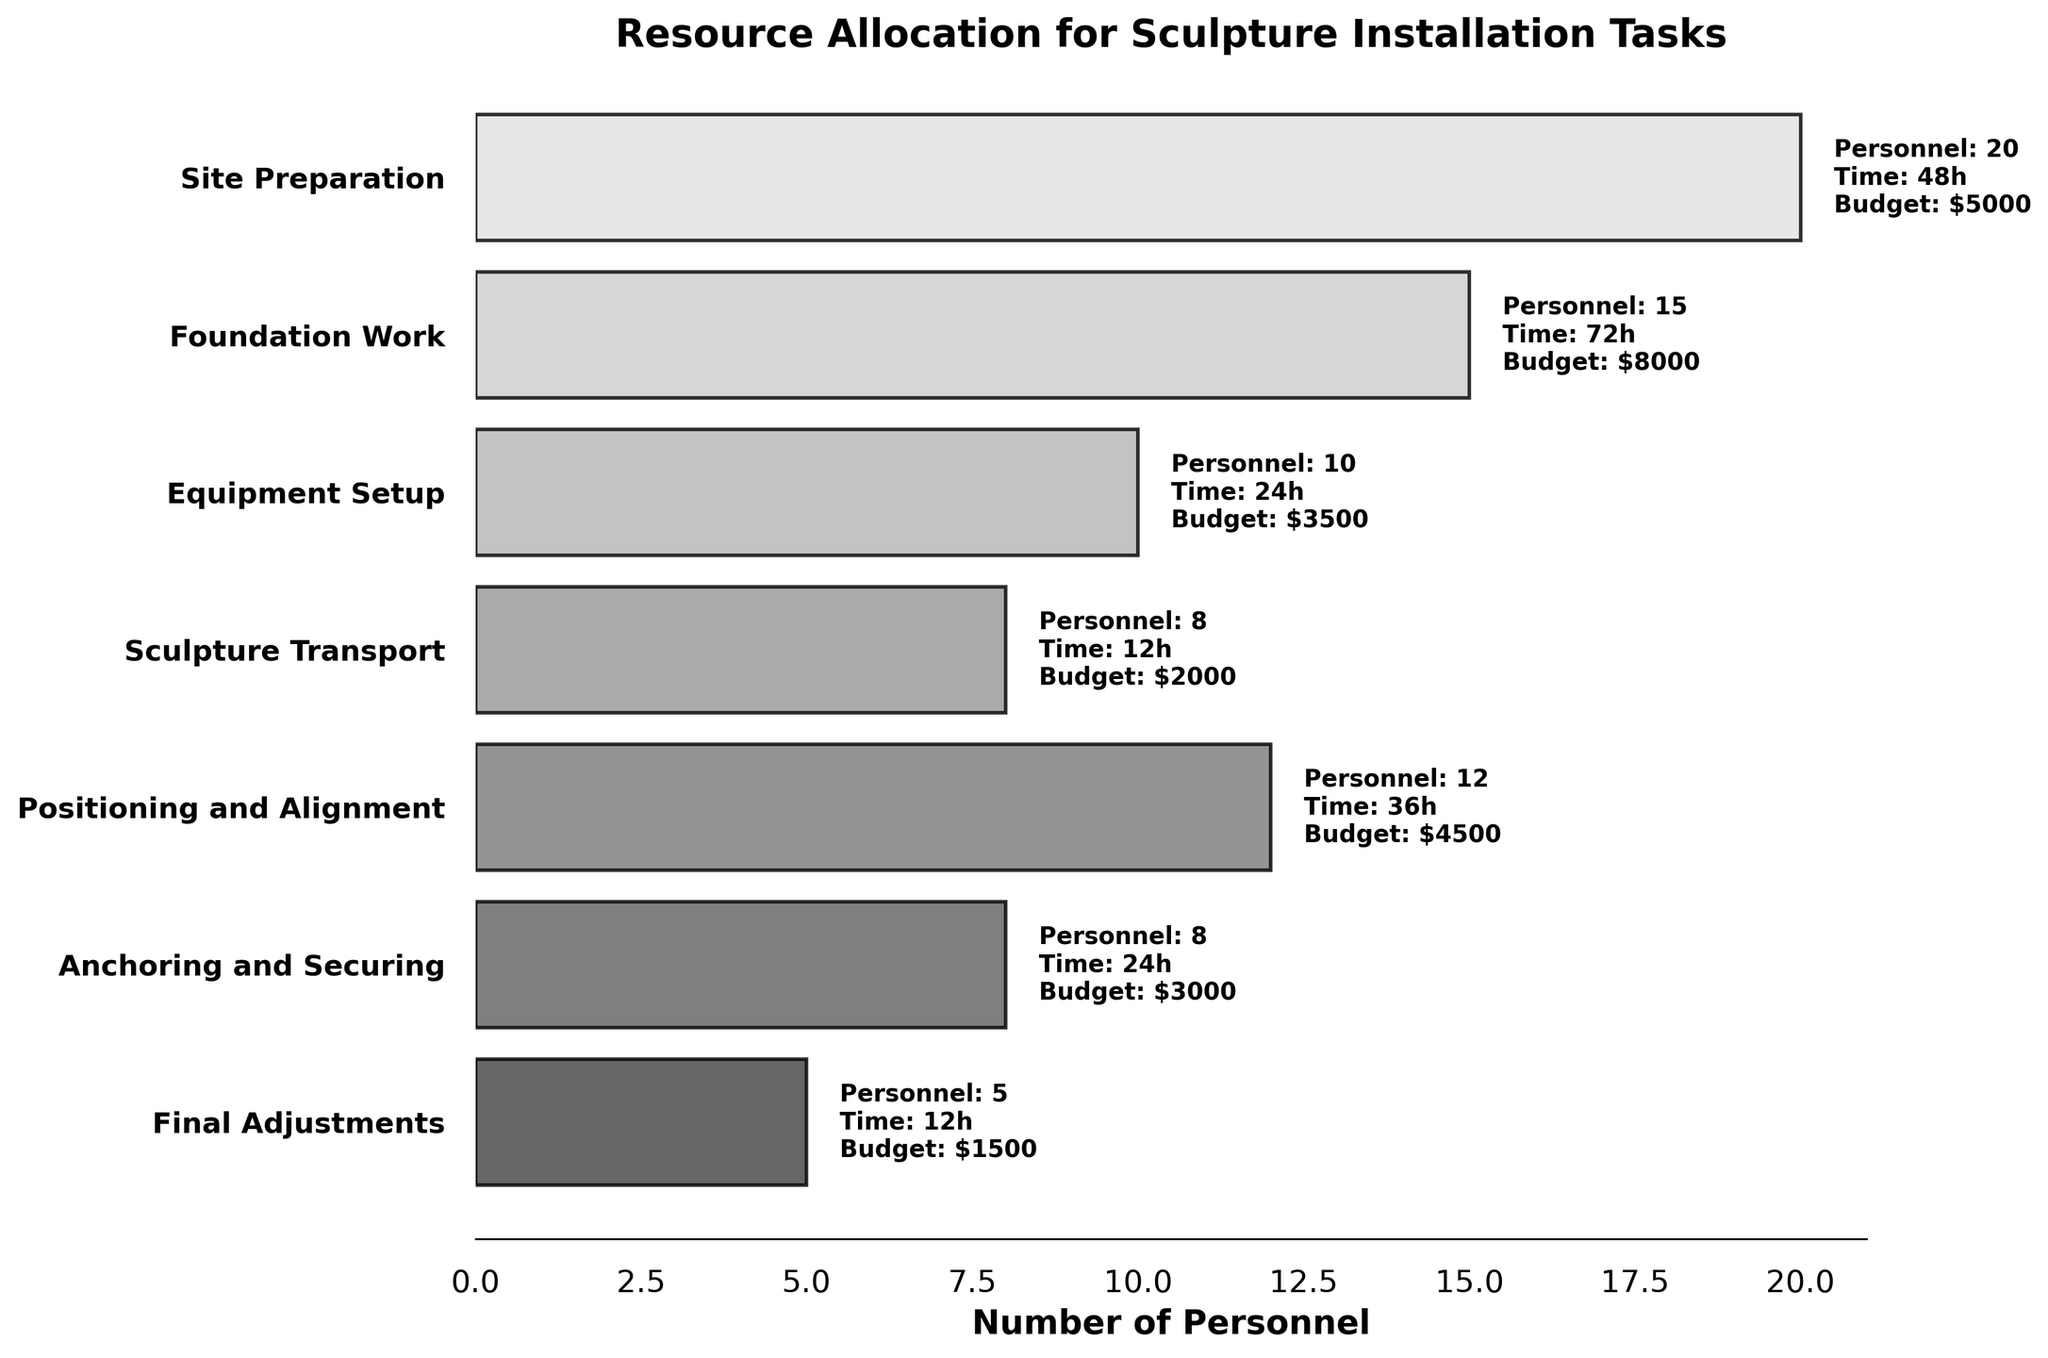what is the total budget allocated for the 'Sculpture Transport' stage? The figure provides the budget for different stages directly. For the 'Sculpture Transport' stage, it is marked as $2000 right next to the bar.
Answer: $2000 which stage requires the maximum number of personnel? By comparing the lengths of the horizontal bars representing the number of personnel, the 'Site Preparation' stage has the longest bar with 20 personnel required.
Answer: Site Preparation how much time is needed in total to complete the 'Foundation Work' and 'Final Adjustments' stages? The time required for 'Foundation Work' is 72 hours, and for 'Final Adjustments' is 12 hours. Adding these together gives 72 + 12 = 84 hours.
Answer: 84 hours what's the average budget for all stages? Sum the budget amounts for all stages (5000 + 8000 + 3500 + 2000 + 4500 + 3000 + 1500 = 27500). There are 7 stages in total. Average budget = 27500 / 7 = 3928.57.
Answer: $3928.57 is the budget for 'Equipment Setup' greater than for 'Positioning and Alignment'? The figure shows that the budget for 'Equipment Setup' is $3500 and for 'Positioning and Alignment' is $4500. Since $3500 is less than $4500, the budget for 'Equipment Setup' is not greater.
Answer: No which stages require fewer than 10 personnel? Observing the personnel count next to each bar, the stages with fewer than 10 personnel are 'Equipment Setup' (10), 'Sculpture Transport' (8), 'Anchoring and Securing' (8), and 'Final Adjustments' (5).
Answer: Sculpture Transport, Anchoring and Securing, Final Adjustments compare the total time needed for 'Anchoring and Securing' and 'Positioning and Alignment'. Which one requires more time? The figure illustrates that 'Anchoring and Securing' requires 24 hours and 'Positioning and Alignment' requires 36 hours. Therefore, 'Positioning and Alignment' requires 12 hours more.
Answer: Positioning and Alignment how many different stages are shown in the figure? By counting the bar labels on the y-axis, there are 7 different stages listed in the figure.
Answer: 7 